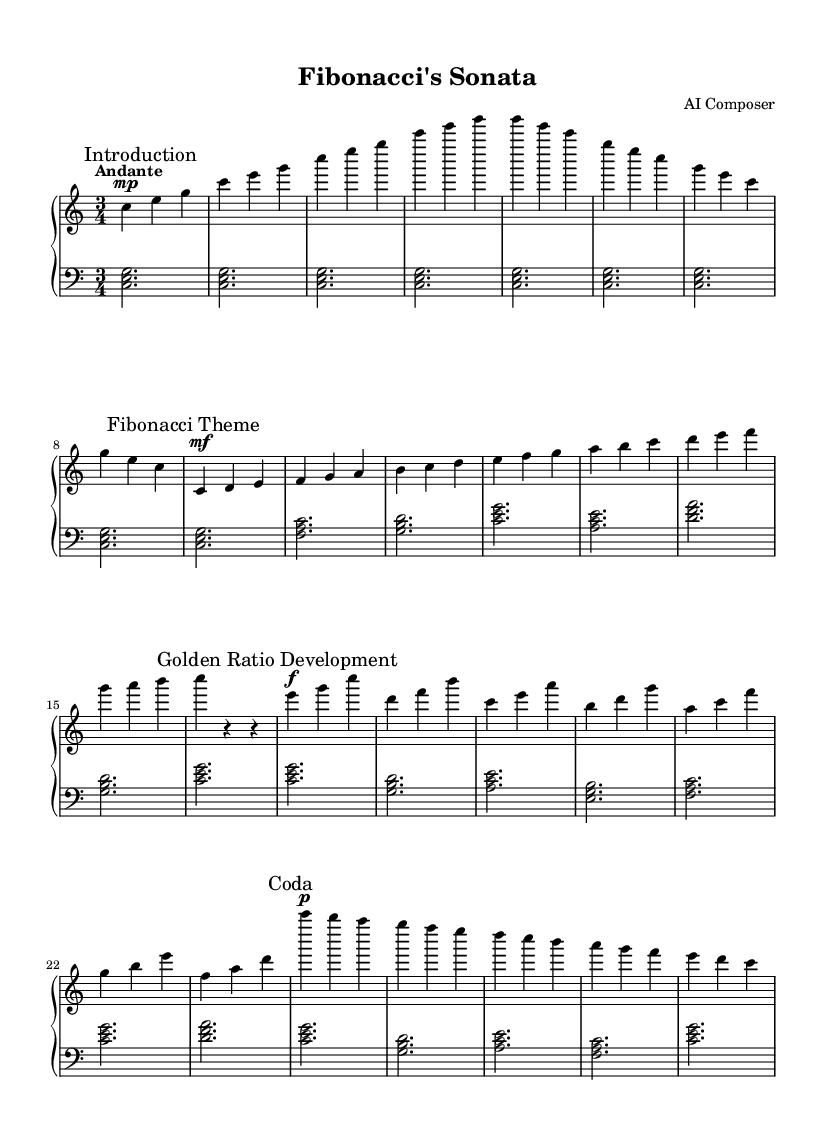What is the key signature of this music? The key signature is C major, which has no sharps or flats.
Answer: C major What is the time signature of this music? The time signature is indicated at the beginning of the score, which shows three beats per measure.
Answer: 3/4 What tempo marking is indicated for the piece? The tempo marking is positioned above the staff and instructs the performer to play at a moderately slow pace.
Answer: Andante What is the dynamic marking at the beginning of the Fibonacci Theme? The dynamic marking indicates a change in volume at the beginning of this section, allowing the performer to play moderately.
Answer: mf How many measures are in the Golden Ratio Development section? By counting the measures in this section of the music, we find that it consists of a specific number of bars that corresponds to the theme's development.
Answer: 6 Which musical form is primarily utilized in this piece? By analyzing the structure and layout of the sections in the music, it resembles a recognizable form that is characteristic of classical pieces.
Answer: Sonata What numerical sequence is employed in the Fibonacci Theme? The notes in this section are arranged according to a specific mathematical sequence, which can be identified through their ascending order.
Answer: Fibonacci 